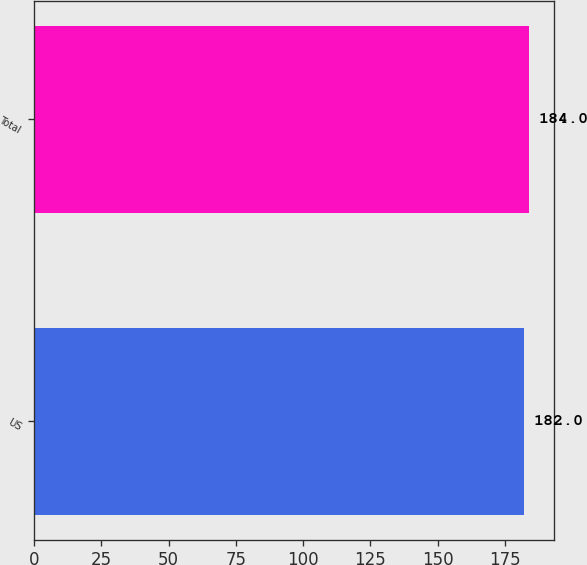<chart> <loc_0><loc_0><loc_500><loc_500><bar_chart><fcel>US<fcel>Total<nl><fcel>182<fcel>184<nl></chart> 